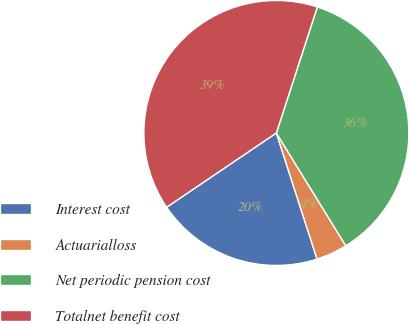Convert chart. <chart><loc_0><loc_0><loc_500><loc_500><pie_chart><fcel>Interest cost<fcel>Actuarialloss<fcel>Net periodic pension cost<fcel>Totalnet benefit cost<nl><fcel>20.5%<fcel>3.81%<fcel>36.22%<fcel>39.47%<nl></chart> 